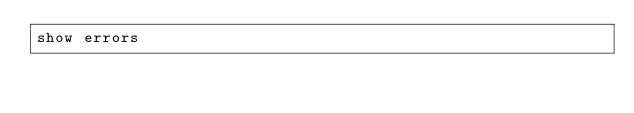<code> <loc_0><loc_0><loc_500><loc_500><_SQL_>show errors</code> 